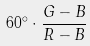<formula> <loc_0><loc_0><loc_500><loc_500>6 0 ^ { \circ } \cdot \frac { G - B } { R - B }</formula> 